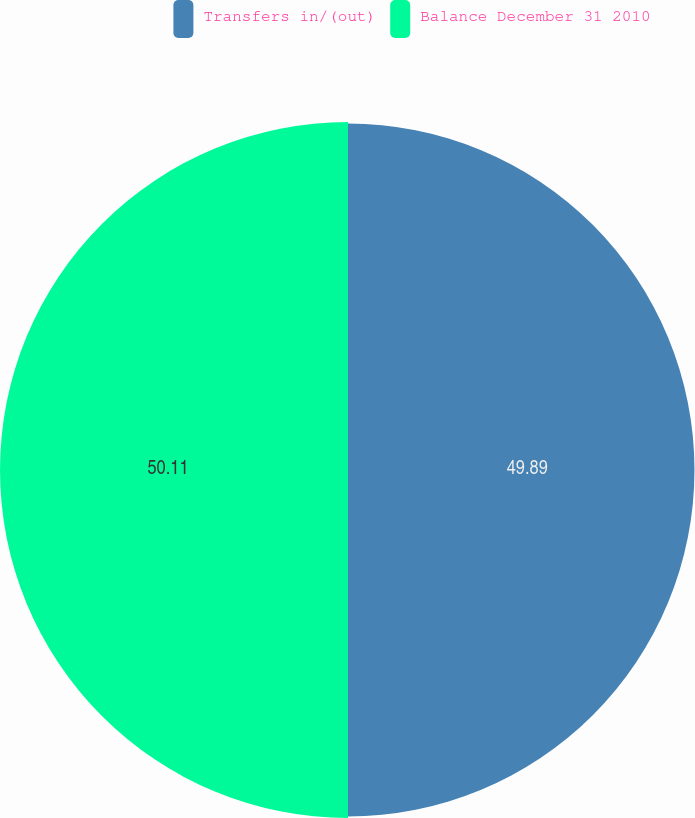Convert chart. <chart><loc_0><loc_0><loc_500><loc_500><pie_chart><fcel>Transfers in/(out)<fcel>Balance December 31 2010<nl><fcel>49.89%<fcel>50.11%<nl></chart> 